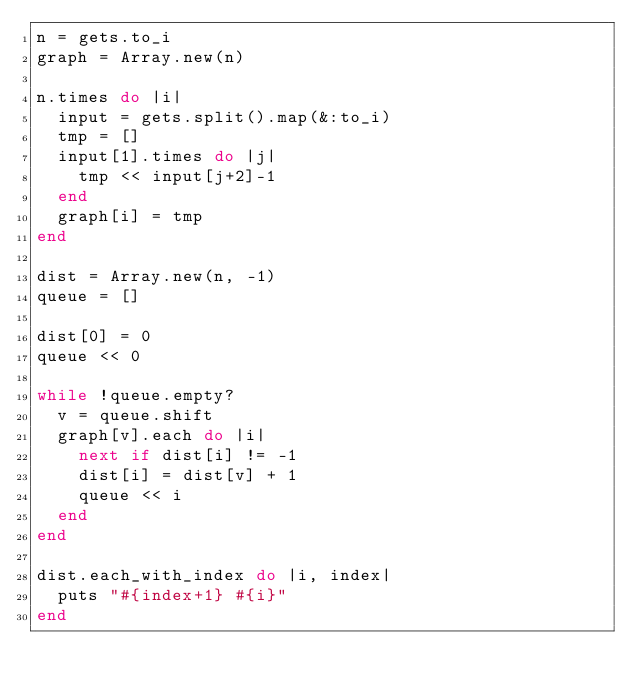Convert code to text. <code><loc_0><loc_0><loc_500><loc_500><_Ruby_>n = gets.to_i
graph = Array.new(n)

n.times do |i|
  input = gets.split().map(&:to_i)
  tmp = []
  input[1].times do |j|
    tmp << input[j+2]-1
  end
  graph[i] = tmp
end

dist = Array.new(n, -1)
queue = []

dist[0] = 0
queue << 0

while !queue.empty?
  v = queue.shift
  graph[v].each do |i|
    next if dist[i] != -1
    dist[i] = dist[v] + 1
    queue << i
  end
end

dist.each_with_index do |i, index|
  puts "#{index+1} #{i}"
end
</code> 